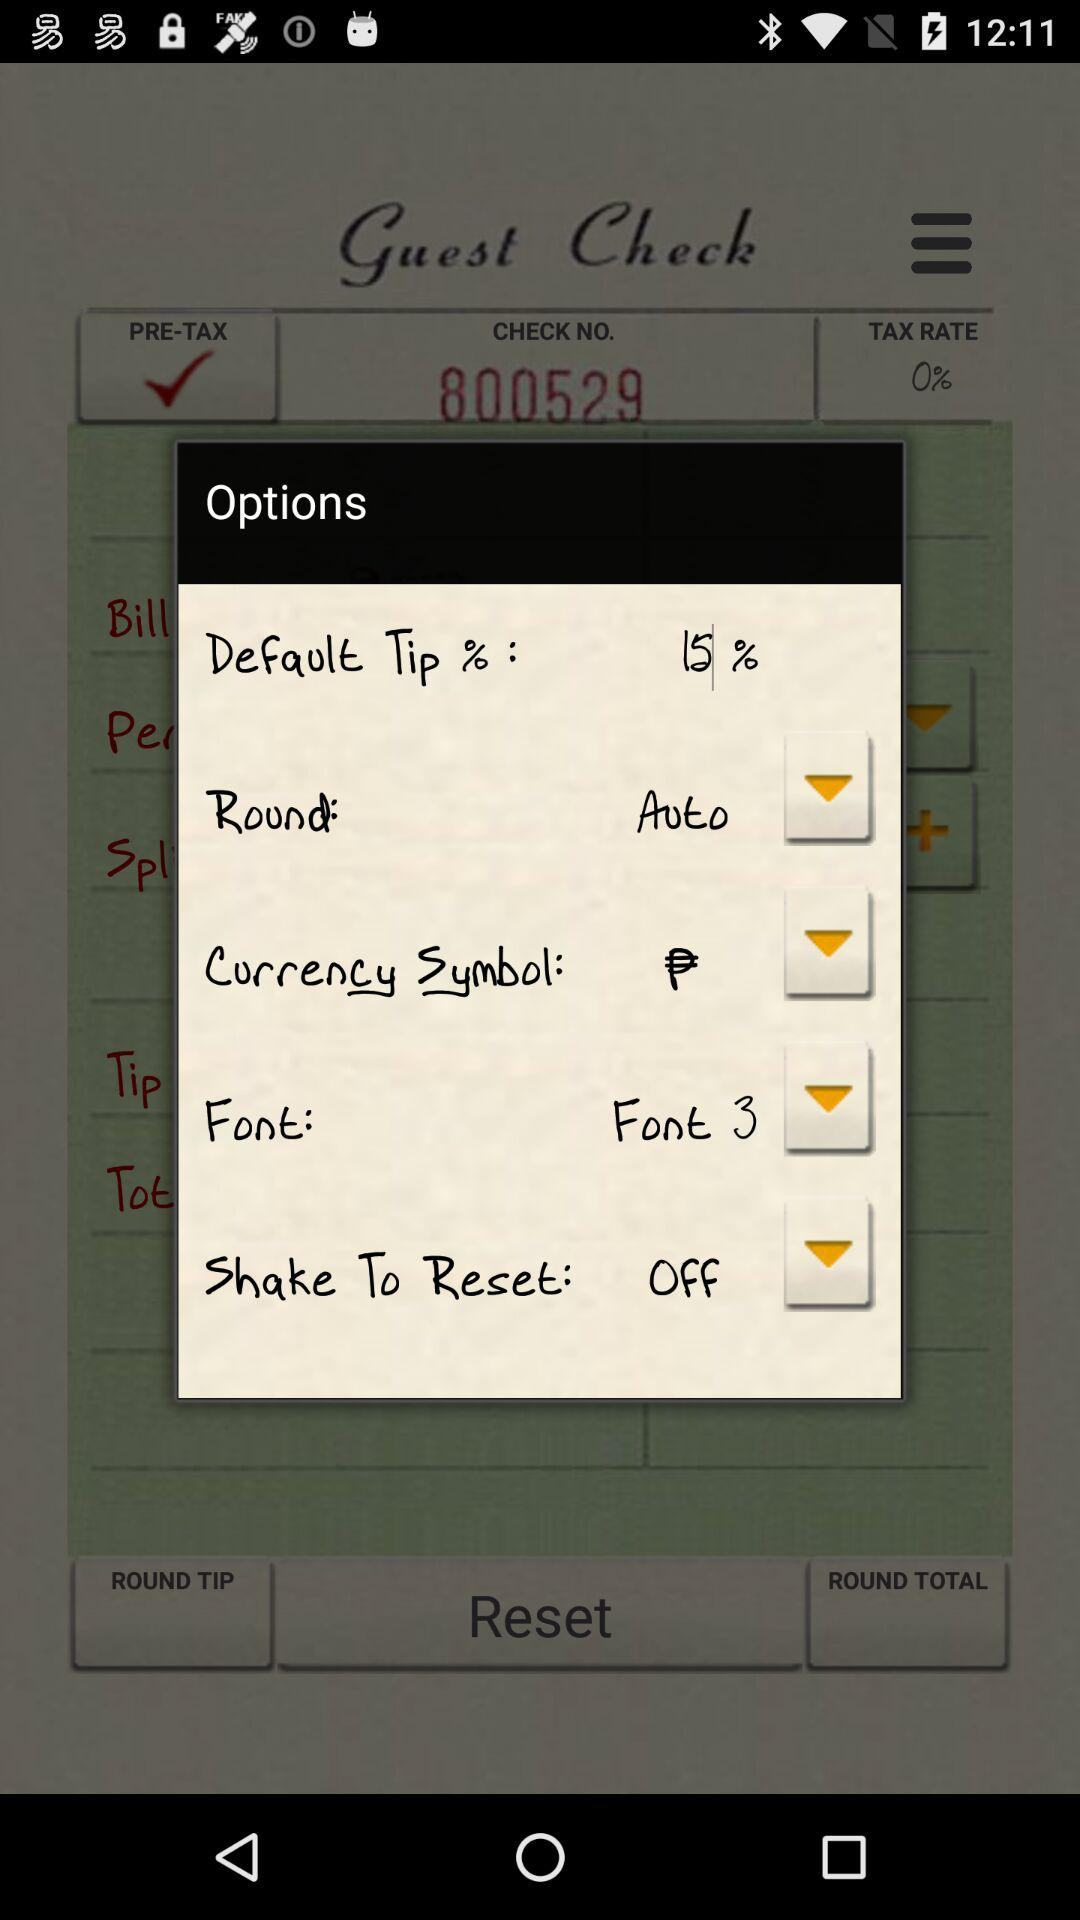What is the selected currency symbol? The selected currency symbol is ₱. 